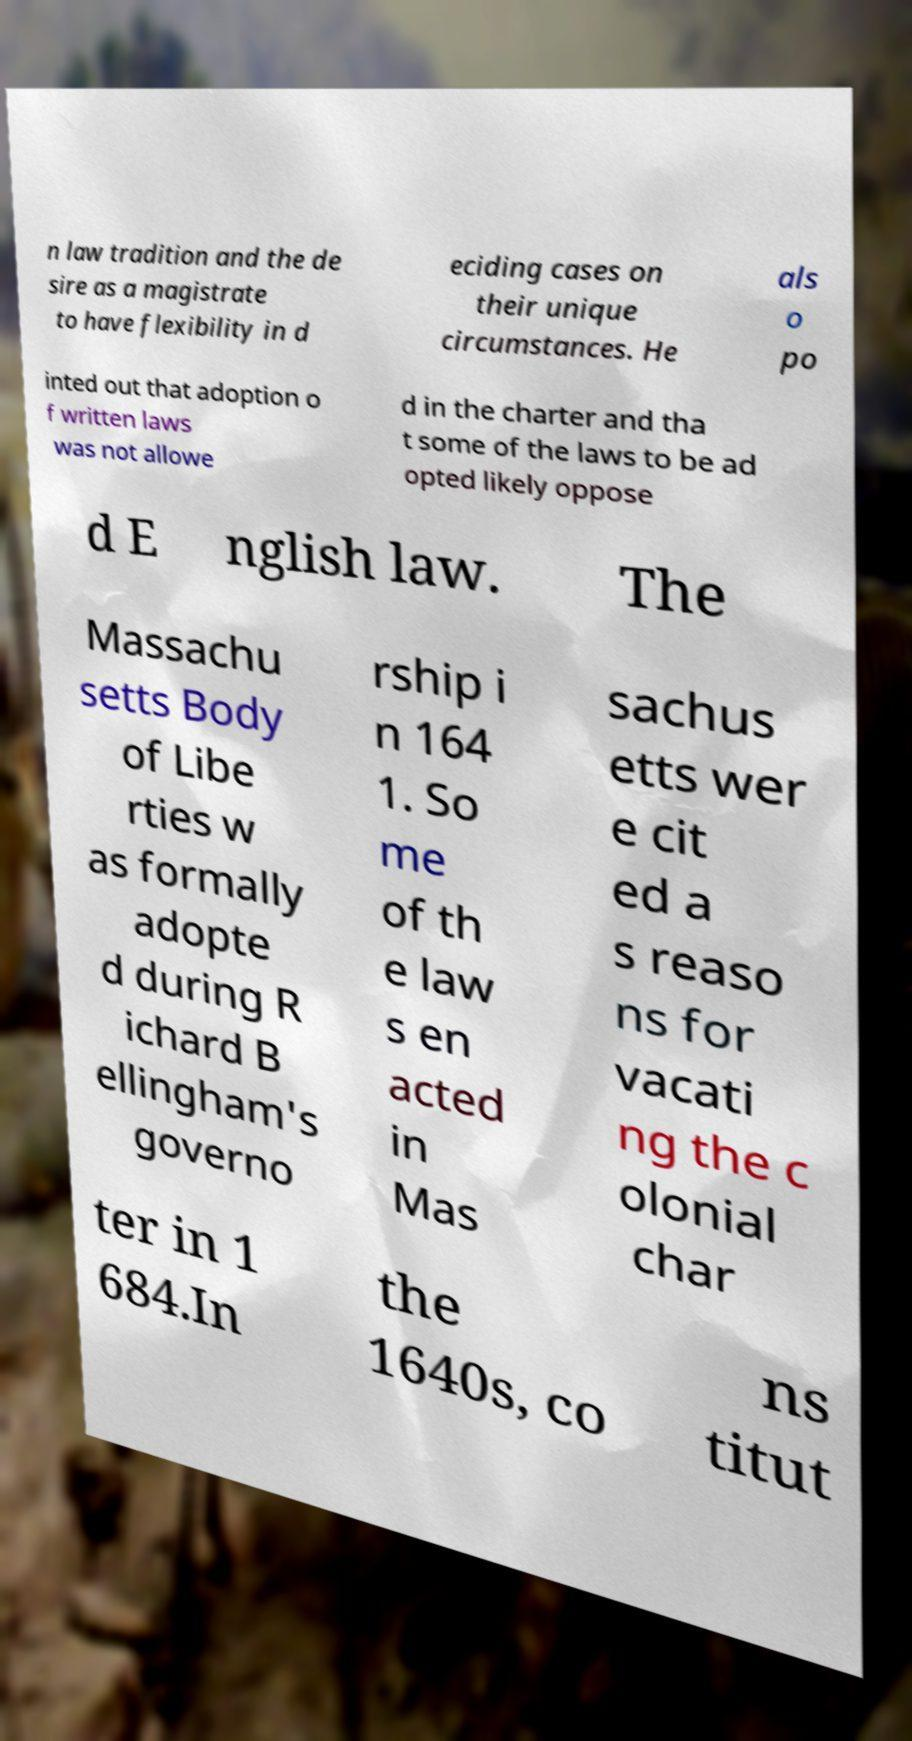Could you assist in decoding the text presented in this image and type it out clearly? n law tradition and the de sire as a magistrate to have flexibility in d eciding cases on their unique circumstances. He als o po inted out that adoption o f written laws was not allowe d in the charter and tha t some of the laws to be ad opted likely oppose d E nglish law. The Massachu setts Body of Libe rties w as formally adopte d during R ichard B ellingham's governo rship i n 164 1. So me of th e law s en acted in Mas sachus etts wer e cit ed a s reaso ns for vacati ng the c olonial char ter in 1 684.In the 1640s, co ns titut 